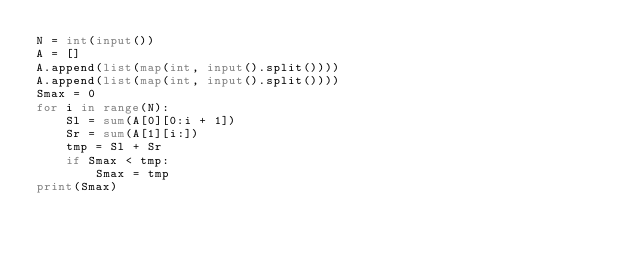Convert code to text. <code><loc_0><loc_0><loc_500><loc_500><_Python_>N = int(input())
A = []
A.append(list(map(int, input().split())))
A.append(list(map(int, input().split())))
Smax = 0
for i in range(N):
    Sl = sum(A[0][0:i + 1])
    Sr = sum(A[1][i:])
    tmp = Sl + Sr
    if Smax < tmp:
        Smax = tmp
print(Smax)</code> 